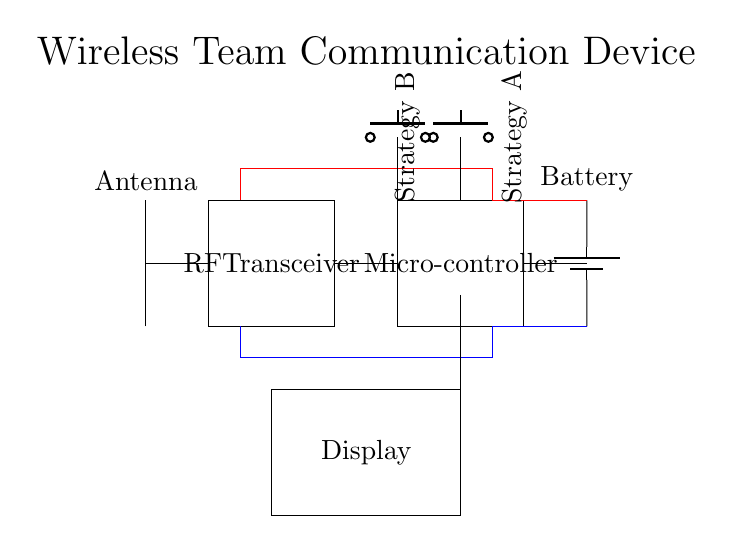What is the main component that transmits data? The RF Transceiver, which is labeled in the circuit, is responsible for transmitting and receiving data wirelessly.
Answer: RF Transceiver How many buttons are used for strategy selection? There are two push buttons labeled for Strategy A and Strategy B, indicating their function for selecting strategies.
Answer: Two What is the power source for this device? The Battery provides the necessary power for the circuit's operation, as indicated by its placement and label.
Answer: Battery Describe the function of the microcontroller in this circuit. The Microcontroller processes the data received from the RF Transceiver and manages the interface with buttons and display. It's crucial for overall control.
Answer: Control Explain how the display is connected to the rest of the circuit. The display is connected to the microcontroller, showing output data after processing. There's a direct line from the microcontroller to the display, indicating this connection.
Answer: Direct line What is the voltage configuration for the circuit? The circuit does not explicitly label the voltage but shows red and blue connections, suggesting it operates on a single battery voltage, typically 3V to 5V.
Answer: 3 to 5 volts What role does the antenna play in this wireless device? The Antenna enables the transmission and reception of radio frequency signals, facilitating the wireless communication between devices.
Answer: Wireless communication 